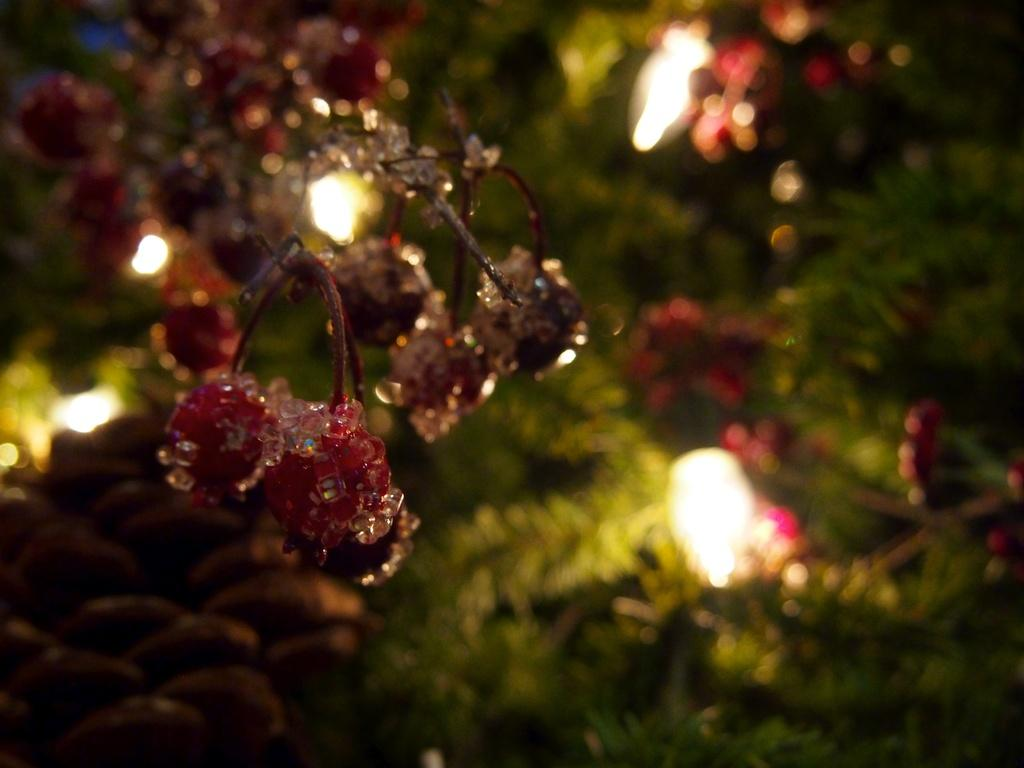What type of food can be seen in the image? There are fruits in the image. What else is present in the image besides the fruits? There are leaves and some objects in the image. Can you describe the background of the image? The background of the image is blurry. What type of structure can be seen in the background of the image? There is no structure visible in the background of the image; it is blurry. What type of tank is present in the image? There is no tank present in the image. 